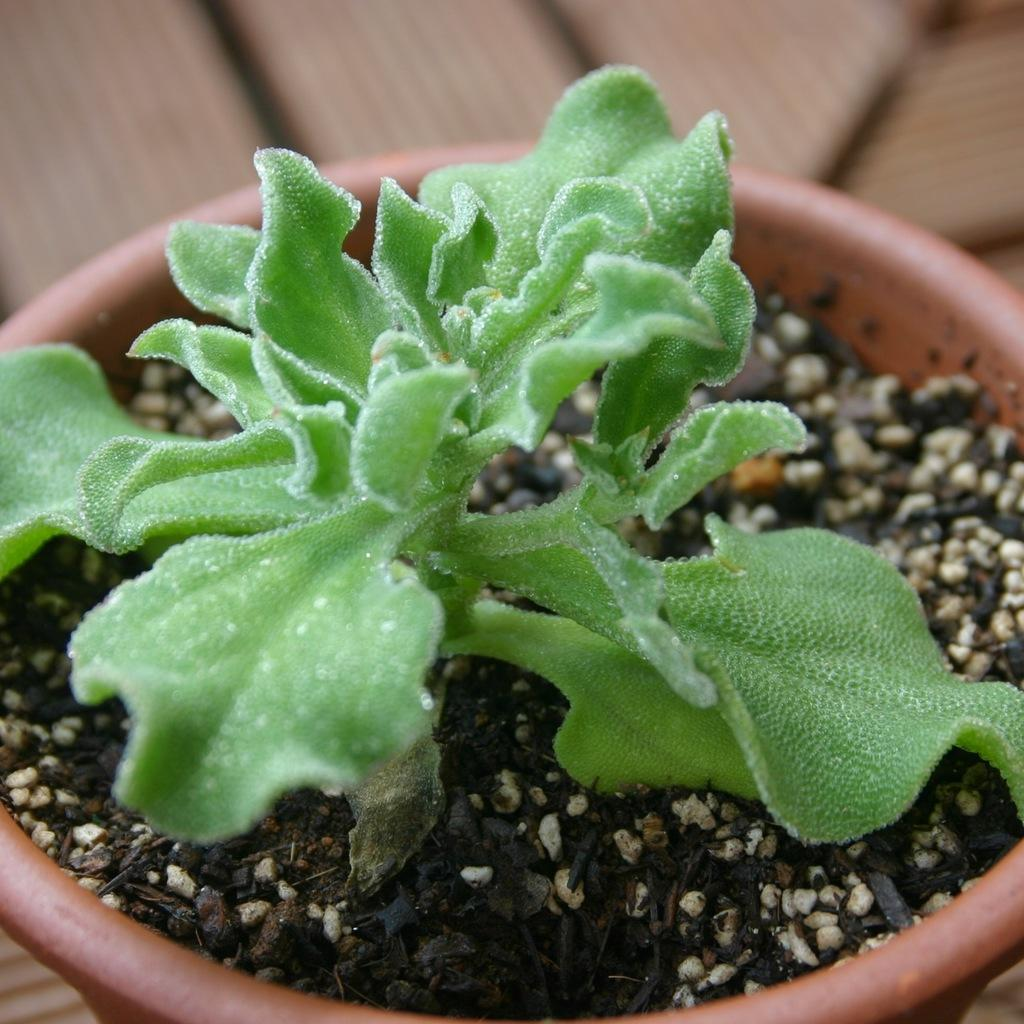What is the main object in the image? There is a pot in the image. What is inside the pot? There is a plant in the pot, along with some other unspecified things. What type of brick is being discussed in the image? There is no brick or discussion about a brick present in the image. What scientific experiment is being conducted in the image? There is no scientific experiment or reference to science in the image. 